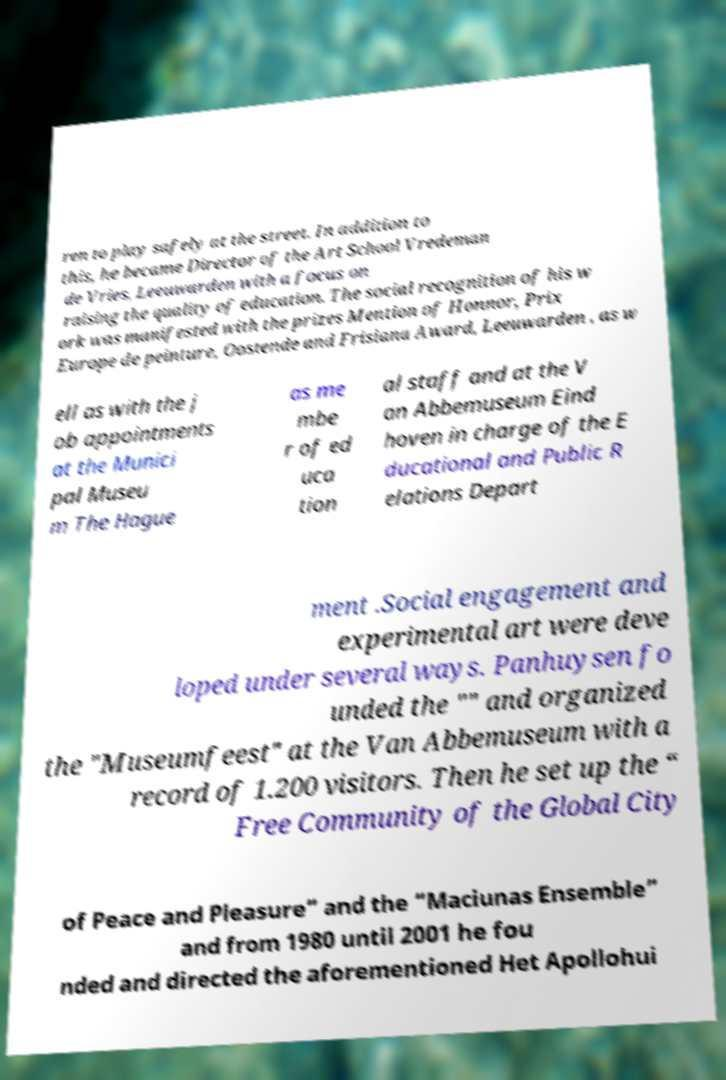What messages or text are displayed in this image? I need them in a readable, typed format. ren to play safely at the street. In addition to this, he became Director of the Art School Vredeman de Vries, Leeuwarden with a focus on raising the quality of education. The social recognition of his w ork was manifested with the prizes Mention of Honnor, Prix Europe de peinture, Oostende and Frisiana Award, Leeuwarden , as w ell as with the j ob appointments at the Munici pal Museu m The Hague as me mbe r of ed uca tion al staff and at the V an Abbemuseum Eind hoven in charge of the E ducational and Public R elations Depart ment .Social engagement and experimental art were deve loped under several ways. Panhuysen fo unded the "" and organized the "Museumfeest" at the Van Abbemuseum with a record of 1.200 visitors. Then he set up the “ Free Community of the Global City of Peace and Pleasure” and the “Maciunas Ensemble” and from 1980 until 2001 he fou nded and directed the aforementioned Het Apollohui 